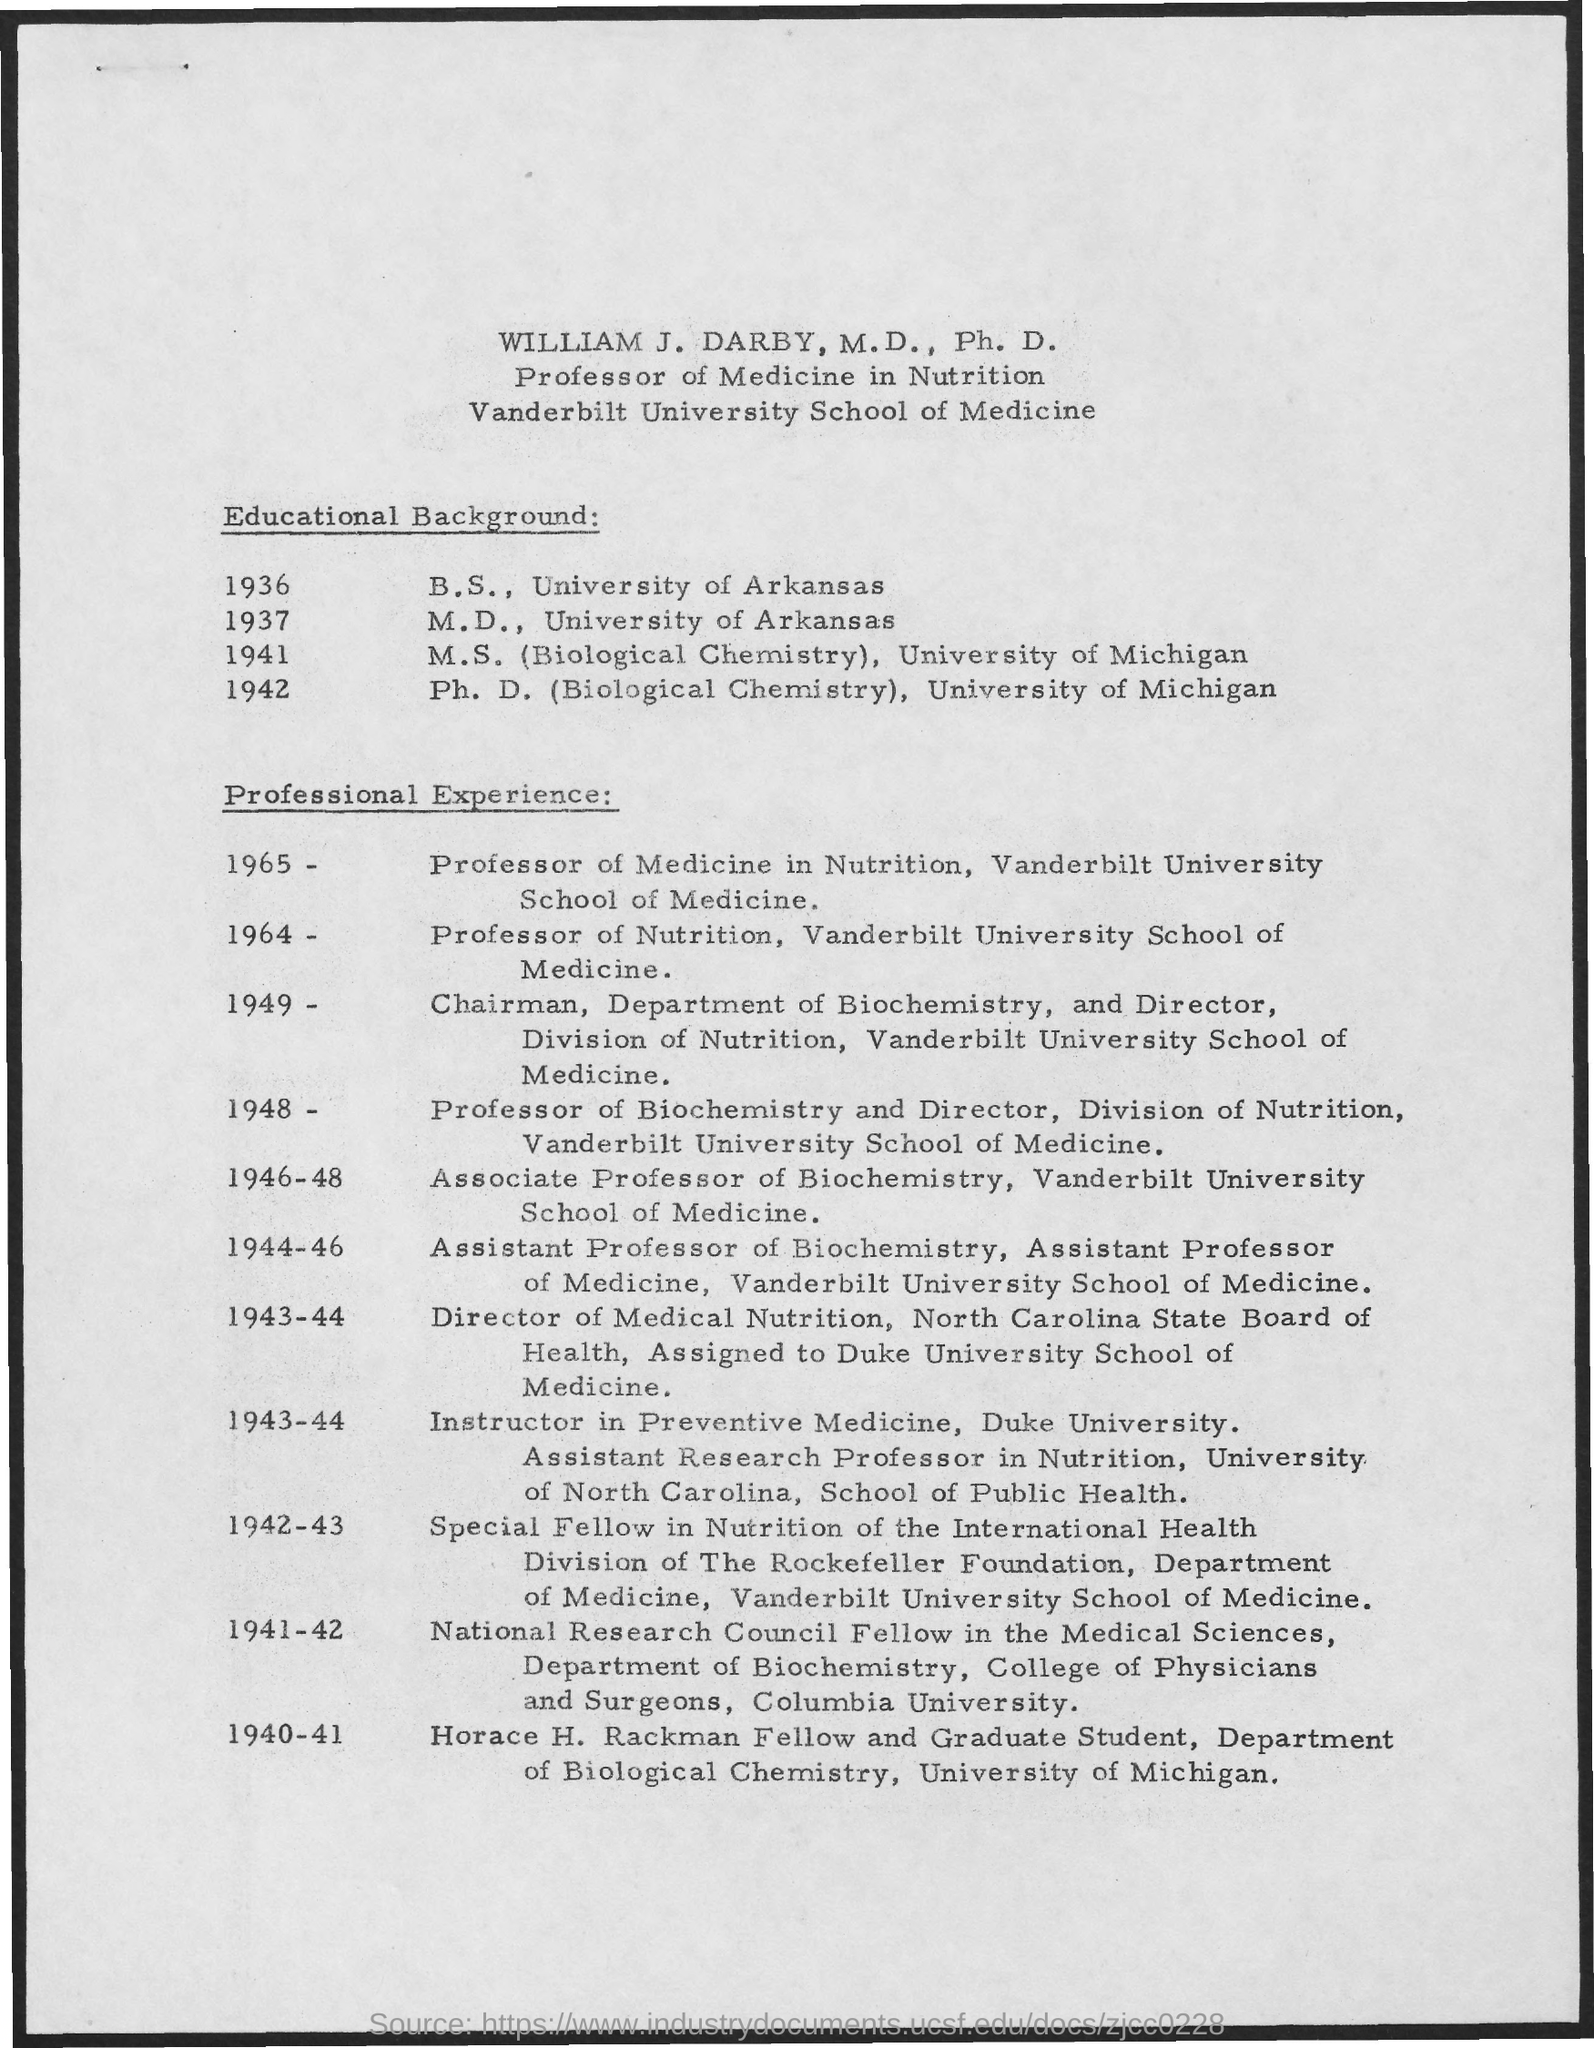What is the designation of WILLIAM J. DARBY, M. D., Ph. D.?
Provide a short and direct response. Professor of Medicine in Nutrition. When did WILLIAM J. DARBY, M. D., Ph. D completed a B.S. in the University of Arkansas?
Ensure brevity in your answer.  1936. In which university, WILLIAM J. DARBY, M. D., Ph. D completed Ph. D. in Biological Chemistry?
Ensure brevity in your answer.  University of Michigan. When did WILLIAM J. DARBY, M. D., Ph. D completed a M.D. in the University of Arkansas?
Your answer should be very brief. 1937. 